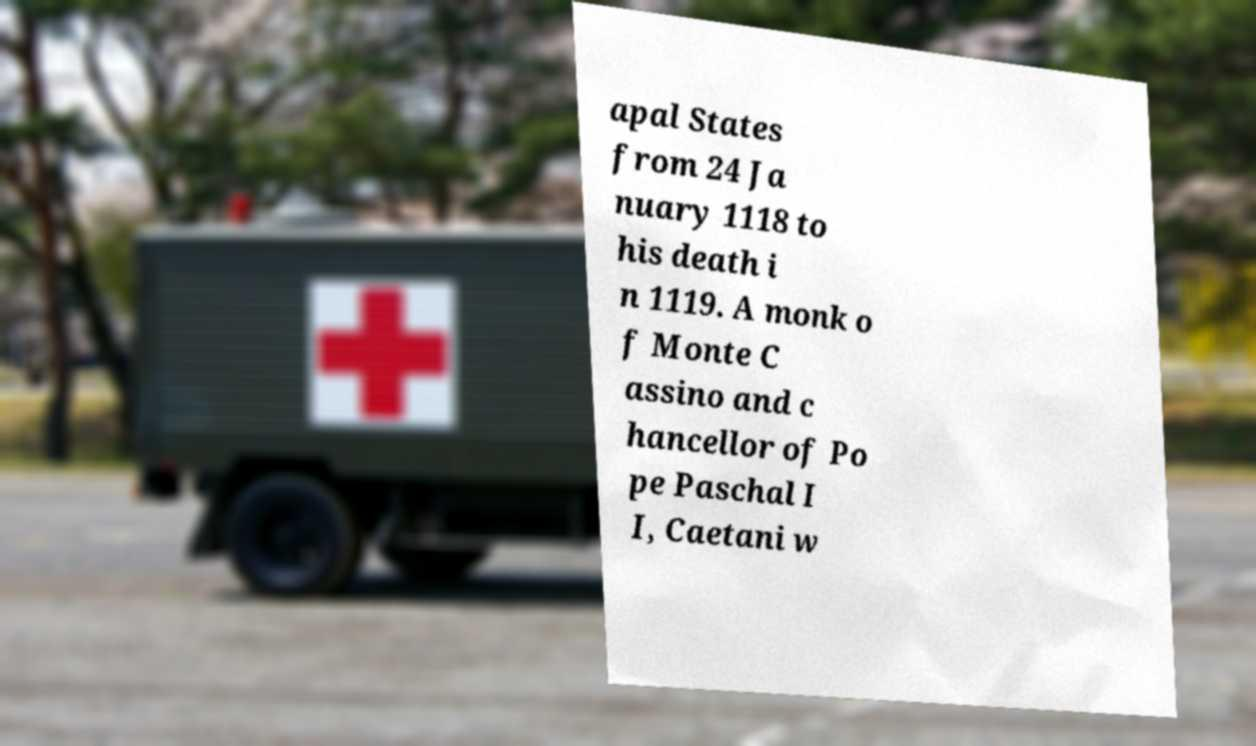What messages or text are displayed in this image? I need them in a readable, typed format. apal States from 24 Ja nuary 1118 to his death i n 1119. A monk o f Monte C assino and c hancellor of Po pe Paschal I I, Caetani w 